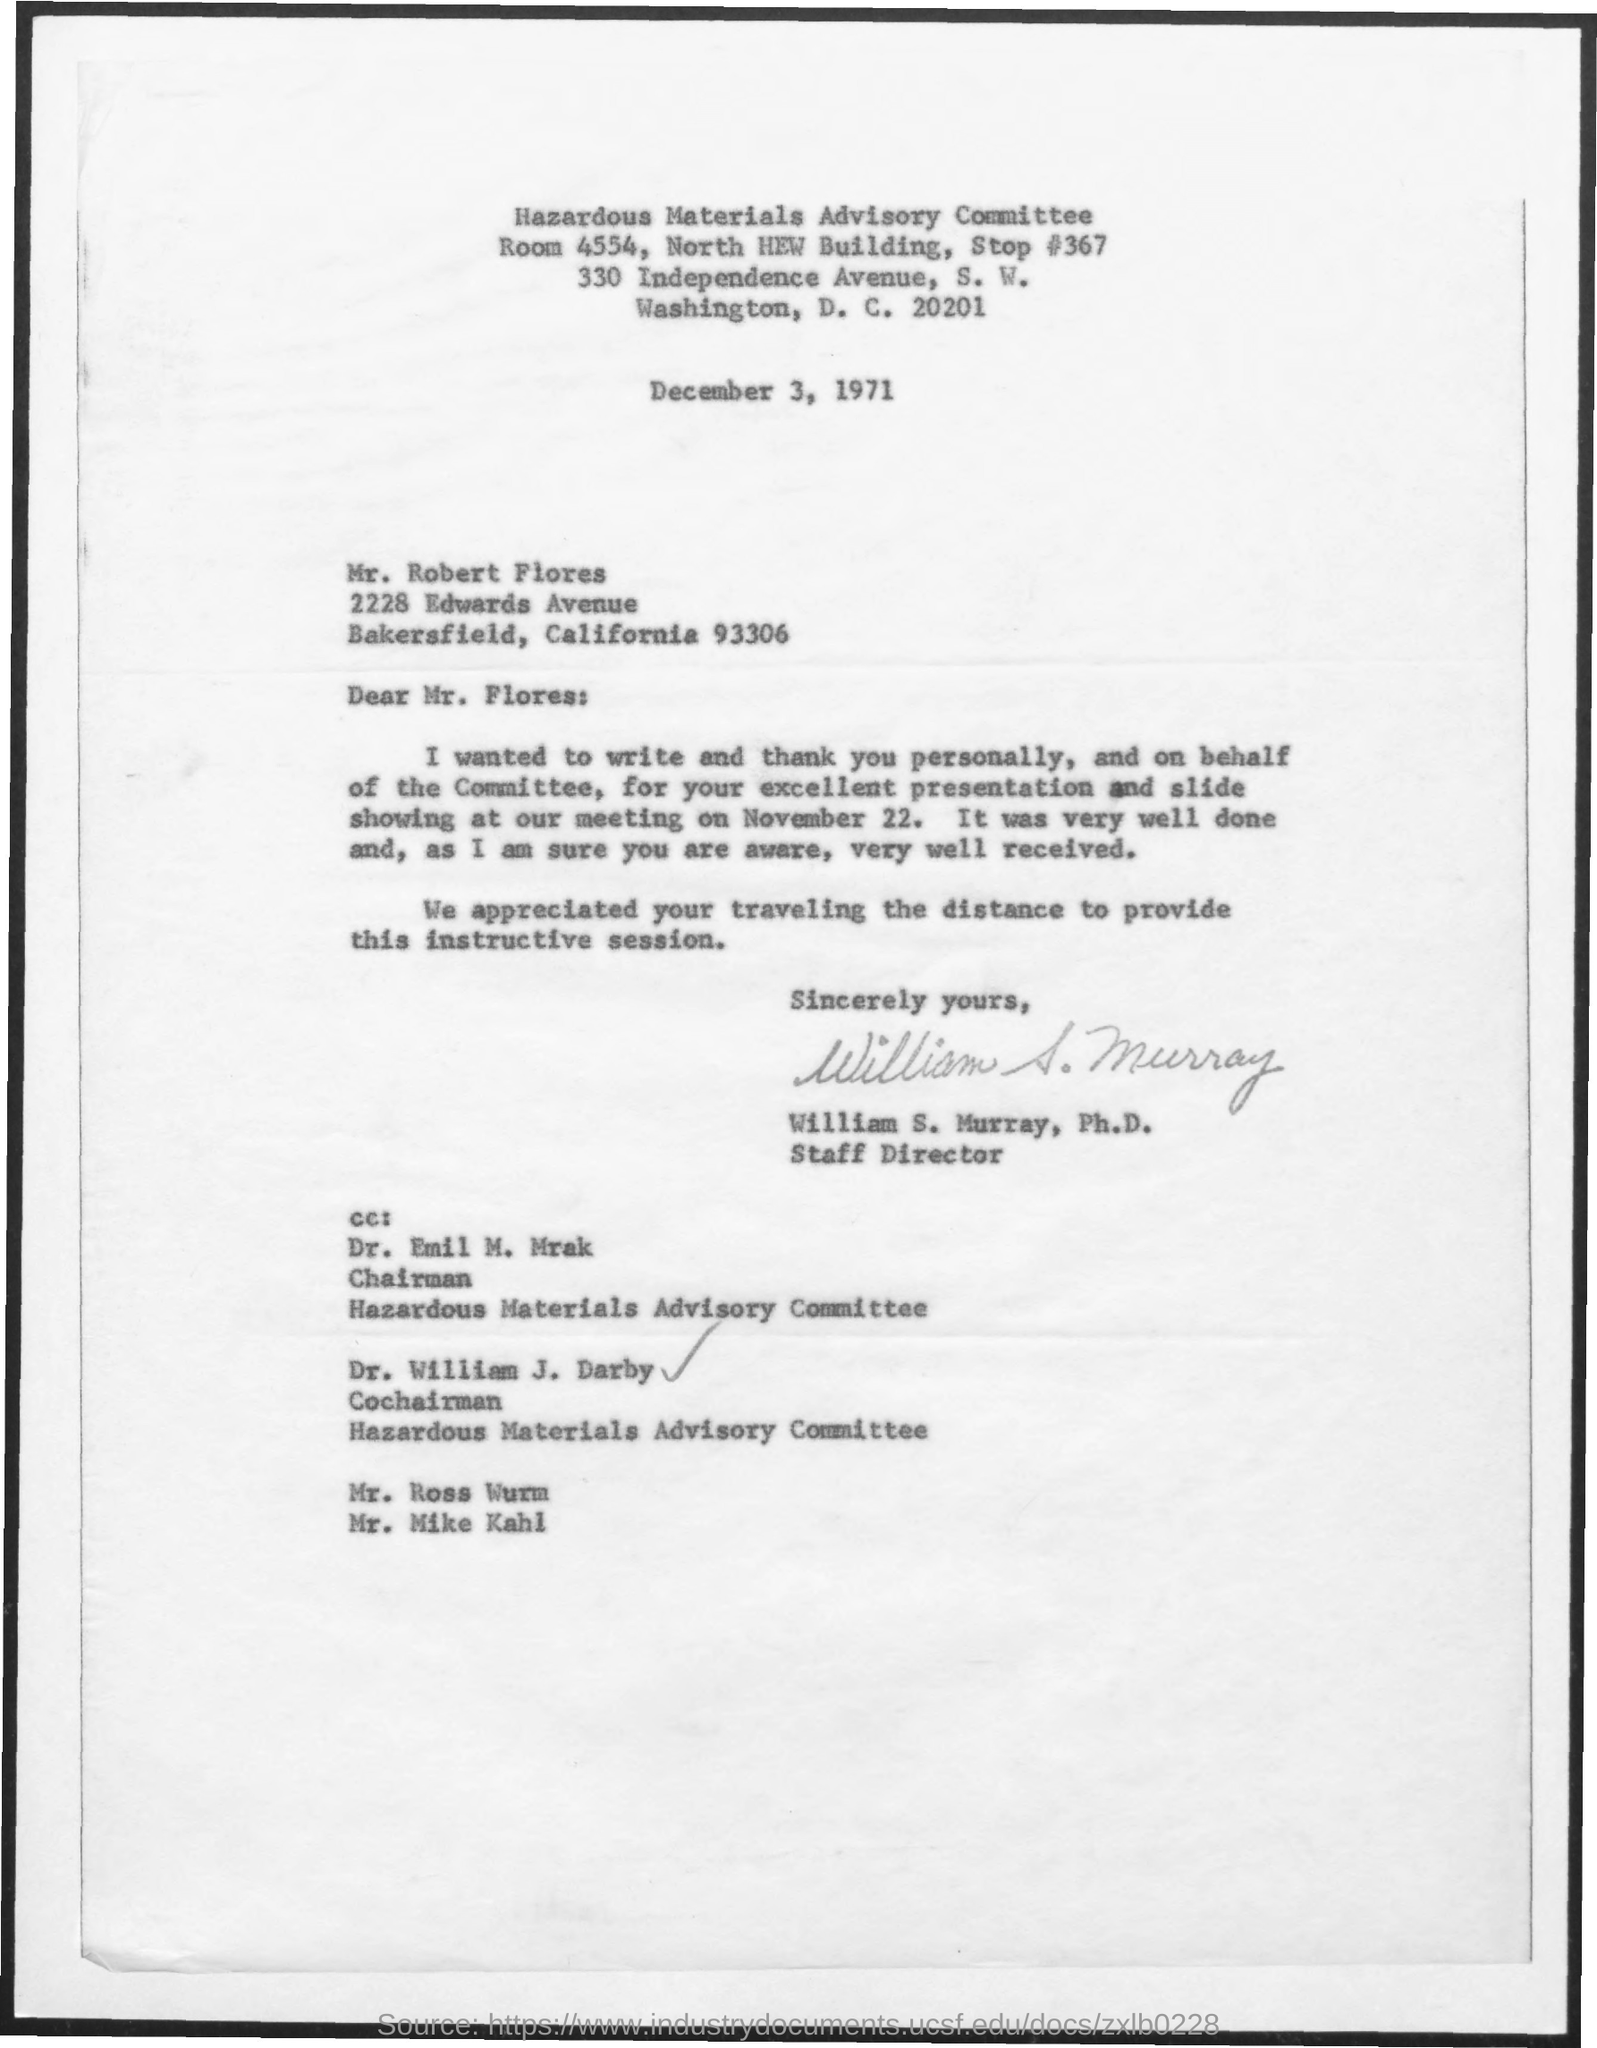Outline some significant characteristics in this image. The Hazardous Materials Advisory Committee is the name of the committee. William S. Murray is the Staff Director. The sender of the letter is William S. Murray. The letter was dated December 3, 1971. Dr. Emil M. Mrak is the Chairman of.. 